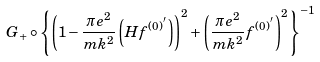<formula> <loc_0><loc_0><loc_500><loc_500>G _ { + } \circ \left \{ \left ( 1 - \frac { \pi e ^ { 2 } } { m k ^ { 2 } } \left ( H f ^ { ( 0 ) ^ { ^ { \prime } } } \right ) \right ) ^ { 2 } + \left ( \frac { \pi e ^ { 2 } } { m k ^ { 2 } } f ^ { ( 0 ) ^ { ^ { \prime } } } \right ) ^ { 2 } \right \} ^ { - 1 }</formula> 